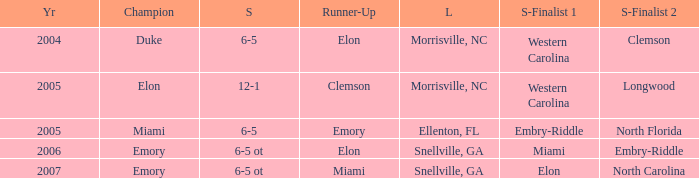Which team was the second semi finalist in 2007? North Carolina. 